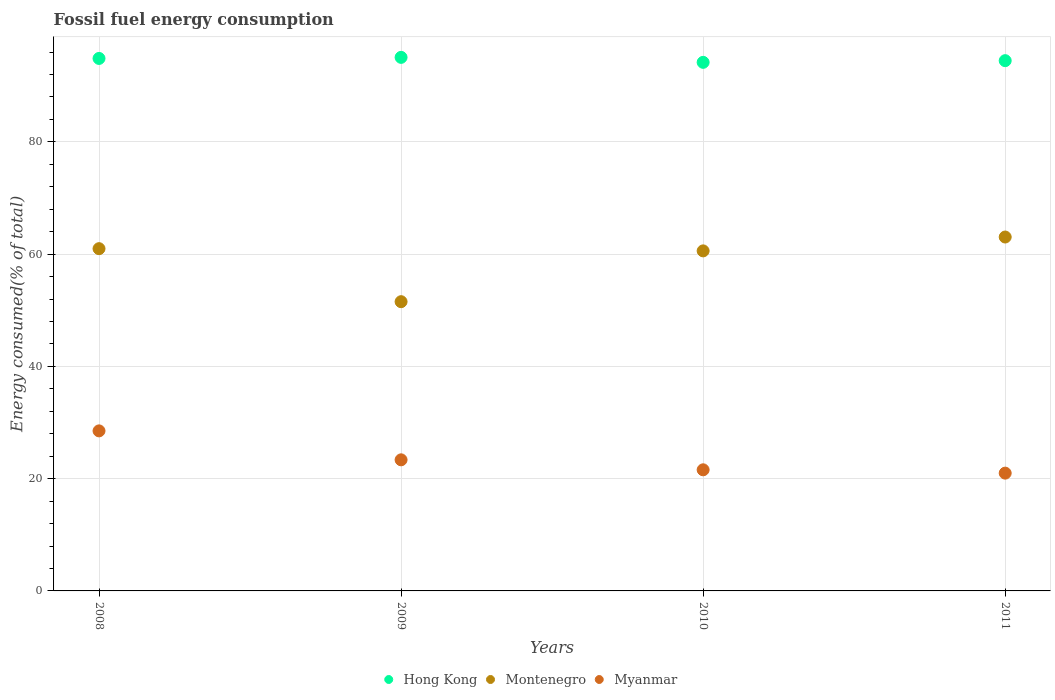How many different coloured dotlines are there?
Make the answer very short. 3. Is the number of dotlines equal to the number of legend labels?
Offer a terse response. Yes. What is the percentage of energy consumed in Myanmar in 2009?
Keep it short and to the point. 23.35. Across all years, what is the maximum percentage of energy consumed in Hong Kong?
Your answer should be compact. 95.05. Across all years, what is the minimum percentage of energy consumed in Myanmar?
Offer a very short reply. 20.98. What is the total percentage of energy consumed in Montenegro in the graph?
Your answer should be very brief. 236.11. What is the difference between the percentage of energy consumed in Montenegro in 2008 and that in 2010?
Offer a terse response. 0.39. What is the difference between the percentage of energy consumed in Myanmar in 2011 and the percentage of energy consumed in Montenegro in 2010?
Make the answer very short. -39.59. What is the average percentage of energy consumed in Myanmar per year?
Offer a terse response. 23.61. In the year 2008, what is the difference between the percentage of energy consumed in Myanmar and percentage of energy consumed in Hong Kong?
Provide a short and direct response. -66.35. What is the ratio of the percentage of energy consumed in Hong Kong in 2008 to that in 2011?
Offer a very short reply. 1. What is the difference between the highest and the second highest percentage of energy consumed in Montenegro?
Your response must be concise. 2.07. What is the difference between the highest and the lowest percentage of energy consumed in Hong Kong?
Your answer should be compact. 0.89. In how many years, is the percentage of energy consumed in Myanmar greater than the average percentage of energy consumed in Myanmar taken over all years?
Offer a very short reply. 1. Is the percentage of energy consumed in Myanmar strictly greater than the percentage of energy consumed in Montenegro over the years?
Provide a succinct answer. No. Does the graph contain any zero values?
Give a very brief answer. No. Where does the legend appear in the graph?
Your answer should be compact. Bottom center. How many legend labels are there?
Give a very brief answer. 3. What is the title of the graph?
Ensure brevity in your answer.  Fossil fuel energy consumption. Does "Montenegro" appear as one of the legend labels in the graph?
Your answer should be very brief. Yes. What is the label or title of the X-axis?
Provide a succinct answer. Years. What is the label or title of the Y-axis?
Your response must be concise. Energy consumed(% of total). What is the Energy consumed(% of total) of Hong Kong in 2008?
Offer a very short reply. 94.86. What is the Energy consumed(% of total) of Montenegro in 2008?
Provide a succinct answer. 60.97. What is the Energy consumed(% of total) in Myanmar in 2008?
Offer a very short reply. 28.51. What is the Energy consumed(% of total) of Hong Kong in 2009?
Provide a succinct answer. 95.05. What is the Energy consumed(% of total) of Montenegro in 2009?
Offer a terse response. 51.53. What is the Energy consumed(% of total) in Myanmar in 2009?
Ensure brevity in your answer.  23.35. What is the Energy consumed(% of total) of Hong Kong in 2010?
Make the answer very short. 94.16. What is the Energy consumed(% of total) in Montenegro in 2010?
Provide a short and direct response. 60.58. What is the Energy consumed(% of total) in Myanmar in 2010?
Provide a succinct answer. 21.58. What is the Energy consumed(% of total) in Hong Kong in 2011?
Provide a short and direct response. 94.46. What is the Energy consumed(% of total) in Montenegro in 2011?
Your answer should be very brief. 63.04. What is the Energy consumed(% of total) of Myanmar in 2011?
Your response must be concise. 20.98. Across all years, what is the maximum Energy consumed(% of total) of Hong Kong?
Provide a short and direct response. 95.05. Across all years, what is the maximum Energy consumed(% of total) in Montenegro?
Give a very brief answer. 63.04. Across all years, what is the maximum Energy consumed(% of total) of Myanmar?
Keep it short and to the point. 28.51. Across all years, what is the minimum Energy consumed(% of total) of Hong Kong?
Your answer should be very brief. 94.16. Across all years, what is the minimum Energy consumed(% of total) of Montenegro?
Provide a short and direct response. 51.53. Across all years, what is the minimum Energy consumed(% of total) of Myanmar?
Give a very brief answer. 20.98. What is the total Energy consumed(% of total) in Hong Kong in the graph?
Make the answer very short. 378.53. What is the total Energy consumed(% of total) of Montenegro in the graph?
Make the answer very short. 236.11. What is the total Energy consumed(% of total) of Myanmar in the graph?
Your answer should be very brief. 94.42. What is the difference between the Energy consumed(% of total) in Hong Kong in 2008 and that in 2009?
Provide a short and direct response. -0.19. What is the difference between the Energy consumed(% of total) in Montenegro in 2008 and that in 2009?
Your answer should be very brief. 9.44. What is the difference between the Energy consumed(% of total) in Myanmar in 2008 and that in 2009?
Give a very brief answer. 5.16. What is the difference between the Energy consumed(% of total) of Hong Kong in 2008 and that in 2010?
Give a very brief answer. 0.7. What is the difference between the Energy consumed(% of total) in Montenegro in 2008 and that in 2010?
Offer a very short reply. 0.39. What is the difference between the Energy consumed(% of total) of Myanmar in 2008 and that in 2010?
Ensure brevity in your answer.  6.94. What is the difference between the Energy consumed(% of total) in Hong Kong in 2008 and that in 2011?
Your response must be concise. 0.4. What is the difference between the Energy consumed(% of total) of Montenegro in 2008 and that in 2011?
Your response must be concise. -2.07. What is the difference between the Energy consumed(% of total) in Myanmar in 2008 and that in 2011?
Offer a very short reply. 7.53. What is the difference between the Energy consumed(% of total) in Hong Kong in 2009 and that in 2010?
Offer a terse response. 0.89. What is the difference between the Energy consumed(% of total) in Montenegro in 2009 and that in 2010?
Provide a short and direct response. -9.05. What is the difference between the Energy consumed(% of total) in Myanmar in 2009 and that in 2010?
Give a very brief answer. 1.78. What is the difference between the Energy consumed(% of total) of Hong Kong in 2009 and that in 2011?
Provide a succinct answer. 0.59. What is the difference between the Energy consumed(% of total) of Montenegro in 2009 and that in 2011?
Your response must be concise. -11.52. What is the difference between the Energy consumed(% of total) of Myanmar in 2009 and that in 2011?
Your answer should be very brief. 2.37. What is the difference between the Energy consumed(% of total) in Hong Kong in 2010 and that in 2011?
Your answer should be very brief. -0.3. What is the difference between the Energy consumed(% of total) in Montenegro in 2010 and that in 2011?
Ensure brevity in your answer.  -2.47. What is the difference between the Energy consumed(% of total) of Myanmar in 2010 and that in 2011?
Offer a terse response. 0.59. What is the difference between the Energy consumed(% of total) of Hong Kong in 2008 and the Energy consumed(% of total) of Montenegro in 2009?
Your answer should be very brief. 43.33. What is the difference between the Energy consumed(% of total) of Hong Kong in 2008 and the Energy consumed(% of total) of Myanmar in 2009?
Your answer should be compact. 71.5. What is the difference between the Energy consumed(% of total) in Montenegro in 2008 and the Energy consumed(% of total) in Myanmar in 2009?
Your answer should be compact. 37.62. What is the difference between the Energy consumed(% of total) in Hong Kong in 2008 and the Energy consumed(% of total) in Montenegro in 2010?
Your answer should be very brief. 34.28. What is the difference between the Energy consumed(% of total) of Hong Kong in 2008 and the Energy consumed(% of total) of Myanmar in 2010?
Your response must be concise. 73.28. What is the difference between the Energy consumed(% of total) in Montenegro in 2008 and the Energy consumed(% of total) in Myanmar in 2010?
Keep it short and to the point. 39.39. What is the difference between the Energy consumed(% of total) in Hong Kong in 2008 and the Energy consumed(% of total) in Montenegro in 2011?
Keep it short and to the point. 31.81. What is the difference between the Energy consumed(% of total) of Hong Kong in 2008 and the Energy consumed(% of total) of Myanmar in 2011?
Make the answer very short. 73.87. What is the difference between the Energy consumed(% of total) of Montenegro in 2008 and the Energy consumed(% of total) of Myanmar in 2011?
Your answer should be very brief. 39.99. What is the difference between the Energy consumed(% of total) of Hong Kong in 2009 and the Energy consumed(% of total) of Montenegro in 2010?
Your answer should be very brief. 34.47. What is the difference between the Energy consumed(% of total) in Hong Kong in 2009 and the Energy consumed(% of total) in Myanmar in 2010?
Make the answer very short. 73.47. What is the difference between the Energy consumed(% of total) in Montenegro in 2009 and the Energy consumed(% of total) in Myanmar in 2010?
Offer a terse response. 29.95. What is the difference between the Energy consumed(% of total) in Hong Kong in 2009 and the Energy consumed(% of total) in Montenegro in 2011?
Provide a short and direct response. 32.01. What is the difference between the Energy consumed(% of total) of Hong Kong in 2009 and the Energy consumed(% of total) of Myanmar in 2011?
Provide a short and direct response. 74.07. What is the difference between the Energy consumed(% of total) in Montenegro in 2009 and the Energy consumed(% of total) in Myanmar in 2011?
Offer a very short reply. 30.54. What is the difference between the Energy consumed(% of total) of Hong Kong in 2010 and the Energy consumed(% of total) of Montenegro in 2011?
Offer a terse response. 31.12. What is the difference between the Energy consumed(% of total) of Hong Kong in 2010 and the Energy consumed(% of total) of Myanmar in 2011?
Give a very brief answer. 73.18. What is the difference between the Energy consumed(% of total) of Montenegro in 2010 and the Energy consumed(% of total) of Myanmar in 2011?
Keep it short and to the point. 39.59. What is the average Energy consumed(% of total) in Hong Kong per year?
Offer a terse response. 94.63. What is the average Energy consumed(% of total) in Montenegro per year?
Your answer should be very brief. 59.03. What is the average Energy consumed(% of total) in Myanmar per year?
Ensure brevity in your answer.  23.61. In the year 2008, what is the difference between the Energy consumed(% of total) of Hong Kong and Energy consumed(% of total) of Montenegro?
Give a very brief answer. 33.89. In the year 2008, what is the difference between the Energy consumed(% of total) of Hong Kong and Energy consumed(% of total) of Myanmar?
Ensure brevity in your answer.  66.35. In the year 2008, what is the difference between the Energy consumed(% of total) in Montenegro and Energy consumed(% of total) in Myanmar?
Ensure brevity in your answer.  32.46. In the year 2009, what is the difference between the Energy consumed(% of total) of Hong Kong and Energy consumed(% of total) of Montenegro?
Offer a very short reply. 43.52. In the year 2009, what is the difference between the Energy consumed(% of total) of Hong Kong and Energy consumed(% of total) of Myanmar?
Provide a succinct answer. 71.7. In the year 2009, what is the difference between the Energy consumed(% of total) in Montenegro and Energy consumed(% of total) in Myanmar?
Your answer should be compact. 28.17. In the year 2010, what is the difference between the Energy consumed(% of total) of Hong Kong and Energy consumed(% of total) of Montenegro?
Your response must be concise. 33.59. In the year 2010, what is the difference between the Energy consumed(% of total) in Hong Kong and Energy consumed(% of total) in Myanmar?
Your response must be concise. 72.59. In the year 2010, what is the difference between the Energy consumed(% of total) of Montenegro and Energy consumed(% of total) of Myanmar?
Your answer should be very brief. 39. In the year 2011, what is the difference between the Energy consumed(% of total) of Hong Kong and Energy consumed(% of total) of Montenegro?
Provide a short and direct response. 31.42. In the year 2011, what is the difference between the Energy consumed(% of total) of Hong Kong and Energy consumed(% of total) of Myanmar?
Offer a very short reply. 73.48. In the year 2011, what is the difference between the Energy consumed(% of total) of Montenegro and Energy consumed(% of total) of Myanmar?
Provide a succinct answer. 42.06. What is the ratio of the Energy consumed(% of total) in Montenegro in 2008 to that in 2009?
Offer a terse response. 1.18. What is the ratio of the Energy consumed(% of total) of Myanmar in 2008 to that in 2009?
Your response must be concise. 1.22. What is the ratio of the Energy consumed(% of total) in Hong Kong in 2008 to that in 2010?
Offer a very short reply. 1.01. What is the ratio of the Energy consumed(% of total) of Montenegro in 2008 to that in 2010?
Provide a short and direct response. 1.01. What is the ratio of the Energy consumed(% of total) in Myanmar in 2008 to that in 2010?
Ensure brevity in your answer.  1.32. What is the ratio of the Energy consumed(% of total) of Montenegro in 2008 to that in 2011?
Provide a short and direct response. 0.97. What is the ratio of the Energy consumed(% of total) of Myanmar in 2008 to that in 2011?
Give a very brief answer. 1.36. What is the ratio of the Energy consumed(% of total) in Hong Kong in 2009 to that in 2010?
Ensure brevity in your answer.  1.01. What is the ratio of the Energy consumed(% of total) of Montenegro in 2009 to that in 2010?
Make the answer very short. 0.85. What is the ratio of the Energy consumed(% of total) of Myanmar in 2009 to that in 2010?
Your answer should be very brief. 1.08. What is the ratio of the Energy consumed(% of total) of Hong Kong in 2009 to that in 2011?
Provide a short and direct response. 1.01. What is the ratio of the Energy consumed(% of total) in Montenegro in 2009 to that in 2011?
Offer a very short reply. 0.82. What is the ratio of the Energy consumed(% of total) in Myanmar in 2009 to that in 2011?
Offer a terse response. 1.11. What is the ratio of the Energy consumed(% of total) in Montenegro in 2010 to that in 2011?
Give a very brief answer. 0.96. What is the ratio of the Energy consumed(% of total) of Myanmar in 2010 to that in 2011?
Give a very brief answer. 1.03. What is the difference between the highest and the second highest Energy consumed(% of total) in Hong Kong?
Ensure brevity in your answer.  0.19. What is the difference between the highest and the second highest Energy consumed(% of total) of Montenegro?
Offer a terse response. 2.07. What is the difference between the highest and the second highest Energy consumed(% of total) in Myanmar?
Your answer should be compact. 5.16. What is the difference between the highest and the lowest Energy consumed(% of total) of Hong Kong?
Your response must be concise. 0.89. What is the difference between the highest and the lowest Energy consumed(% of total) of Montenegro?
Make the answer very short. 11.52. What is the difference between the highest and the lowest Energy consumed(% of total) in Myanmar?
Provide a short and direct response. 7.53. 